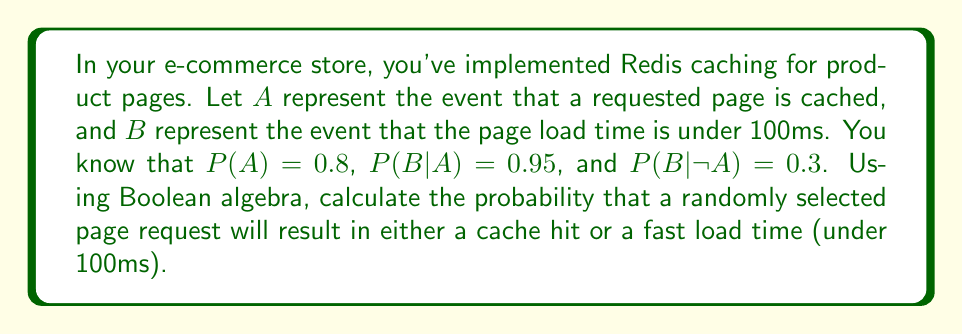Show me your answer to this math problem. Let's approach this step-by-step using Boolean algebra and probability theory:

1) We need to find P(A ∨ B), where ∨ represents the logical OR operation.

2) Using the principle of inclusion-exclusion, we can express this as:
   
   P(A ∨ B) = P(A) + P(B) - P(A ∧ B)

3) We're given P(A) = 0.8, but we need to calculate P(B) and P(A ∧ B).

4) To find P(B), we can use the law of total probability:
   
   P(B) = P(B|A) * P(A) + P(B|not A) * P(not A)
   
   P(B) = 0.95 * 0.8 + 0.3 * (1 - 0.8)
   P(B) = 0.76 + 0.06 = 0.82

5) To find P(A ∧ B), we can use the definition of conditional probability:
   
   P(A ∧ B) = P(B|A) * P(A)
   P(A ∧ B) = 0.95 * 0.8 = 0.76

6) Now we can substitute these values into our original equation:

   P(A ∨ B) = P(A) + P(B) - P(A ∧ B)
   P(A ∨ B) = 0.8 + 0.82 - 0.76
   P(A ∨ B) = 0.86

Therefore, the probability that a randomly selected page request will result in either a cache hit or a fast load time is 0.86 or 86%.
Answer: 0.86 